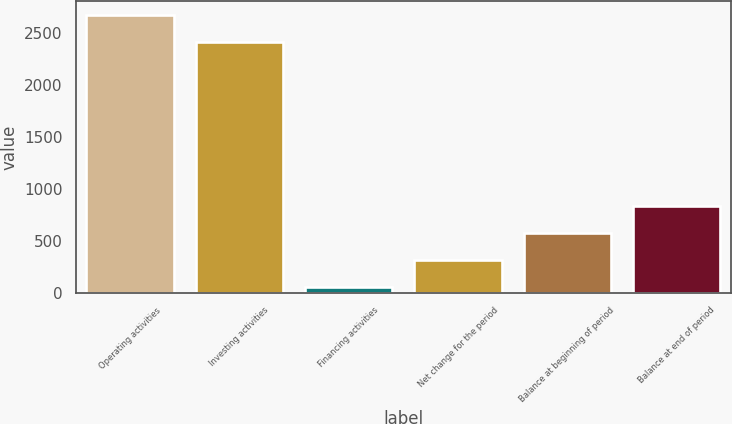Convert chart. <chart><loc_0><loc_0><loc_500><loc_500><bar_chart><fcel>Operating activities<fcel>Investing activities<fcel>Financing activities<fcel>Net change for the period<fcel>Balance at beginning of period<fcel>Balance at end of period<nl><fcel>2675.9<fcel>2417<fcel>54<fcel>312.9<fcel>571.8<fcel>830.7<nl></chart> 